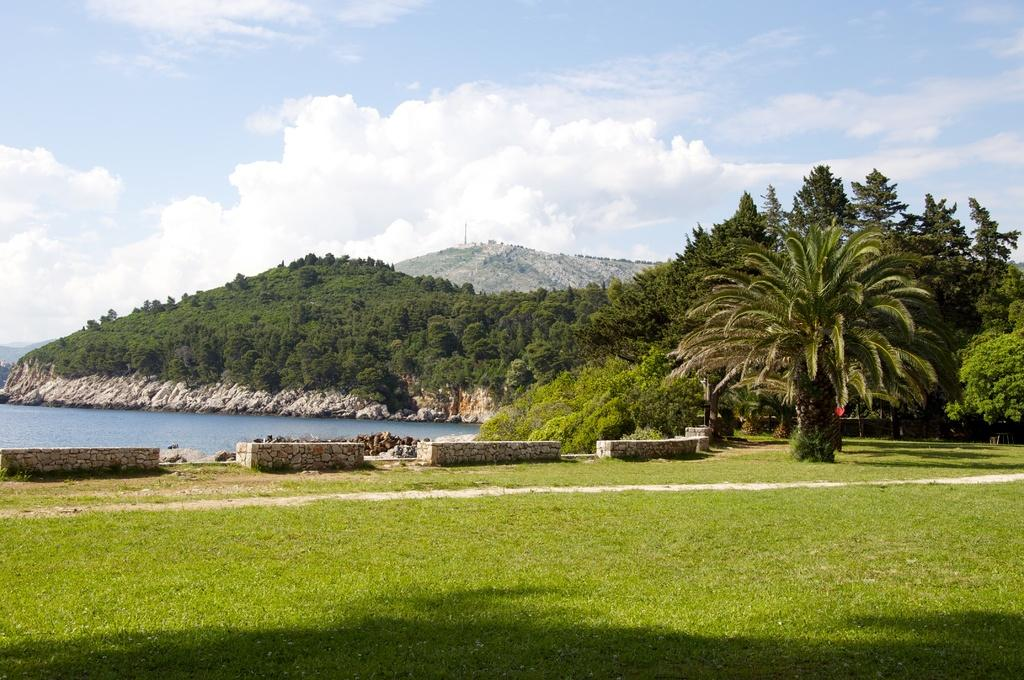What type of terrain is visible in the image? There is grass on the ground in the image. What type of structures are visible in the image? There are walls visible in the image. What type of natural elements are present in the image? Stones and water are present in the image. What type of vegetation can be seen in the background of the image? Trees are present in the background of the image. What type of geological features are visible in the background of the image? Mountains are visible in the background of the image. What is visible in the sky in the image? The sky is visible in the background of the image, and clouds are present in the sky. How many beds are visible in the image? There are no beds present in the image. What type of company is conducting business in the image? There is no company conducting business in the image. 